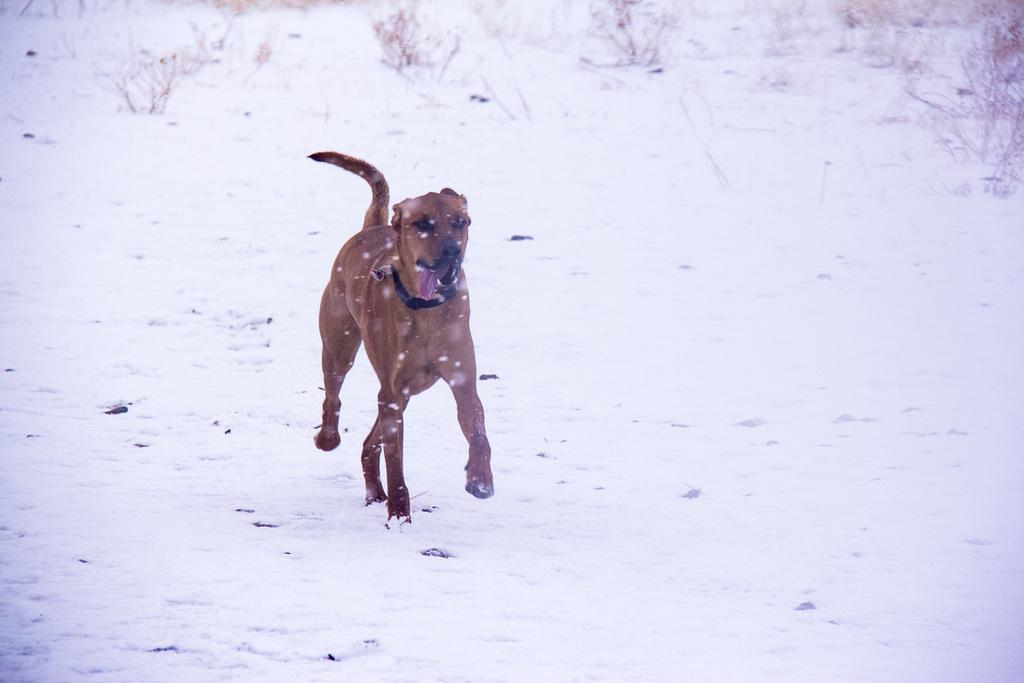What animal can be seen in the image? There is a dog in the image. What type of surface is the dog standing on? The dog is on a snow floor. What can be seen in the background of the image? There are plants visible in the background of the image. What type of seed is the dog planting in the snow? There is no seed or planting activity present in the image; the dog is simply standing on the snow floor. 